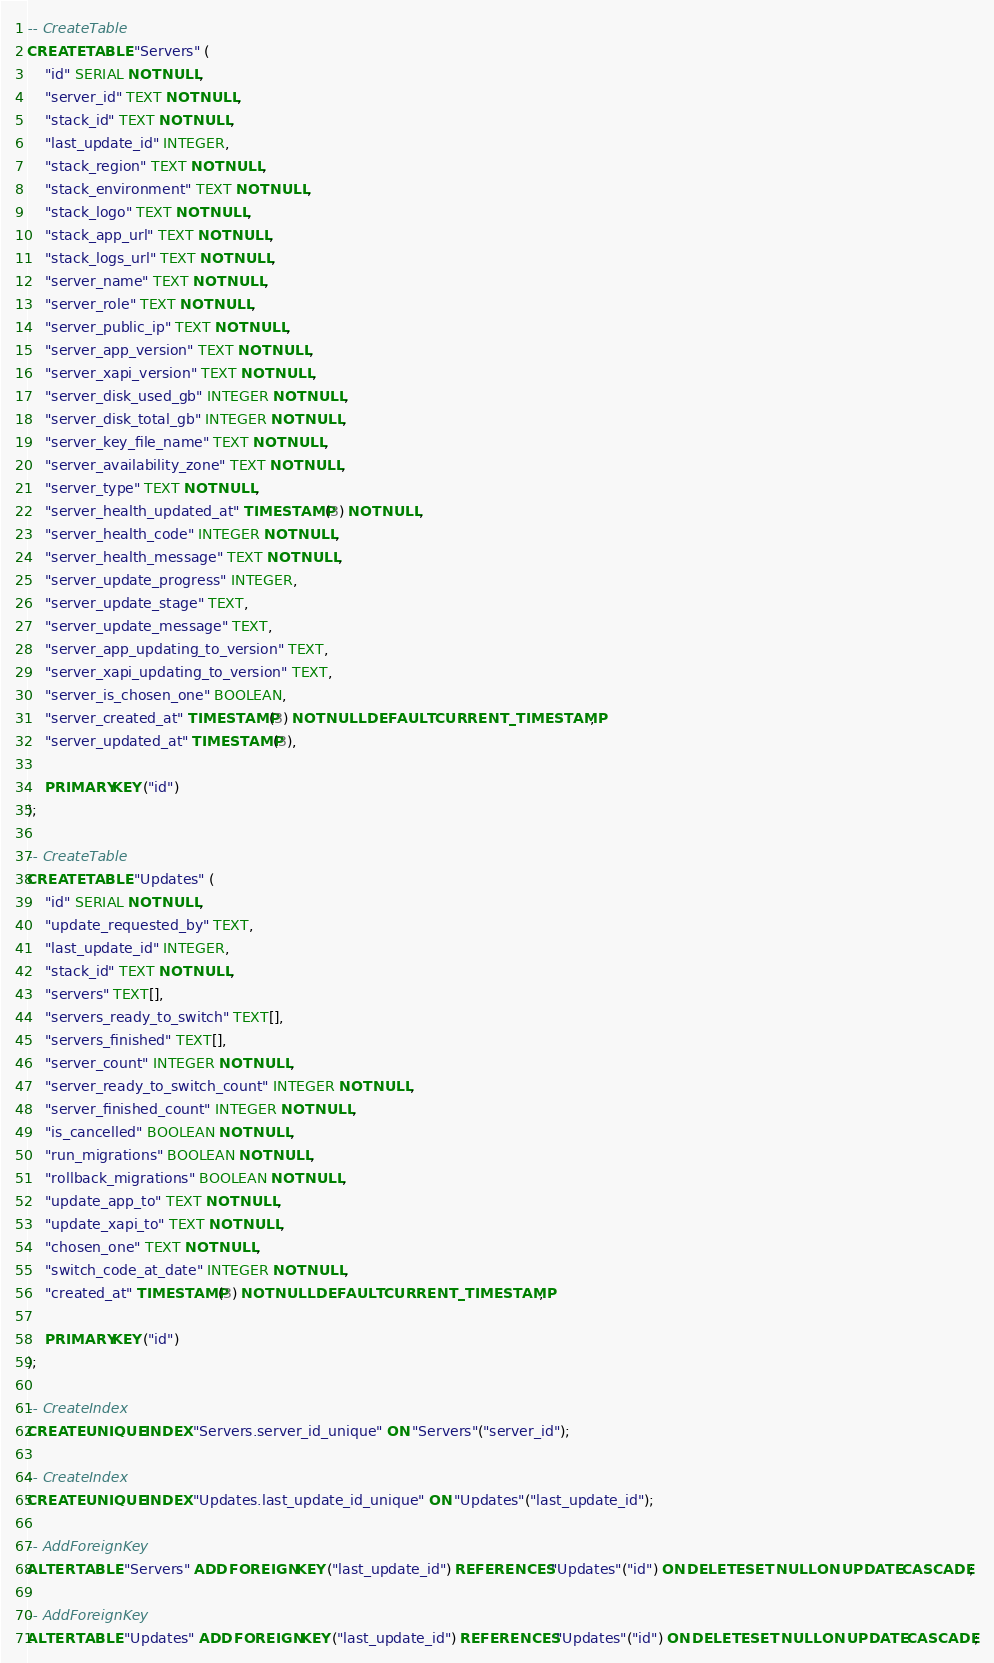Convert code to text. <code><loc_0><loc_0><loc_500><loc_500><_SQL_>-- CreateTable
CREATE TABLE "Servers" (
    "id" SERIAL NOT NULL,
    "server_id" TEXT NOT NULL,
    "stack_id" TEXT NOT NULL,
    "last_update_id" INTEGER,
    "stack_region" TEXT NOT NULL,
    "stack_environment" TEXT NOT NULL,
    "stack_logo" TEXT NOT NULL,
    "stack_app_url" TEXT NOT NULL,
    "stack_logs_url" TEXT NOT NULL,
    "server_name" TEXT NOT NULL,
    "server_role" TEXT NOT NULL,
    "server_public_ip" TEXT NOT NULL,
    "server_app_version" TEXT NOT NULL,
    "server_xapi_version" TEXT NOT NULL,
    "server_disk_used_gb" INTEGER NOT NULL,
    "server_disk_total_gb" INTEGER NOT NULL,
    "server_key_file_name" TEXT NOT NULL,
    "server_availability_zone" TEXT NOT NULL,
    "server_type" TEXT NOT NULL,
    "server_health_updated_at" TIMESTAMP(3) NOT NULL,
    "server_health_code" INTEGER NOT NULL,
    "server_health_message" TEXT NOT NULL,
    "server_update_progress" INTEGER,
    "server_update_stage" TEXT,
    "server_update_message" TEXT,
    "server_app_updating_to_version" TEXT,
    "server_xapi_updating_to_version" TEXT,
    "server_is_chosen_one" BOOLEAN,
    "server_created_at" TIMESTAMP(3) NOT NULL DEFAULT CURRENT_TIMESTAMP,
    "server_updated_at" TIMESTAMP(3),

    PRIMARY KEY ("id")
);

-- CreateTable
CREATE TABLE "Updates" (
    "id" SERIAL NOT NULL,
    "update_requested_by" TEXT,
    "last_update_id" INTEGER,
    "stack_id" TEXT NOT NULL,
    "servers" TEXT[],
    "servers_ready_to_switch" TEXT[],
    "servers_finished" TEXT[],
    "server_count" INTEGER NOT NULL,
    "server_ready_to_switch_count" INTEGER NOT NULL,
    "server_finished_count" INTEGER NOT NULL,
    "is_cancelled" BOOLEAN NOT NULL,
    "run_migrations" BOOLEAN NOT NULL,
    "rollback_migrations" BOOLEAN NOT NULL,
    "update_app_to" TEXT NOT NULL,
    "update_xapi_to" TEXT NOT NULL,
    "chosen_one" TEXT NOT NULL,
    "switch_code_at_date" INTEGER NOT NULL,
    "created_at" TIMESTAMP(3) NOT NULL DEFAULT CURRENT_TIMESTAMP,

    PRIMARY KEY ("id")
);

-- CreateIndex
CREATE UNIQUE INDEX "Servers.server_id_unique" ON "Servers"("server_id");

-- CreateIndex
CREATE UNIQUE INDEX "Updates.last_update_id_unique" ON "Updates"("last_update_id");

-- AddForeignKey
ALTER TABLE "Servers" ADD FOREIGN KEY ("last_update_id") REFERENCES "Updates"("id") ON DELETE SET NULL ON UPDATE CASCADE;

-- AddForeignKey
ALTER TABLE "Updates" ADD FOREIGN KEY ("last_update_id") REFERENCES "Updates"("id") ON DELETE SET NULL ON UPDATE CASCADE;
</code> 